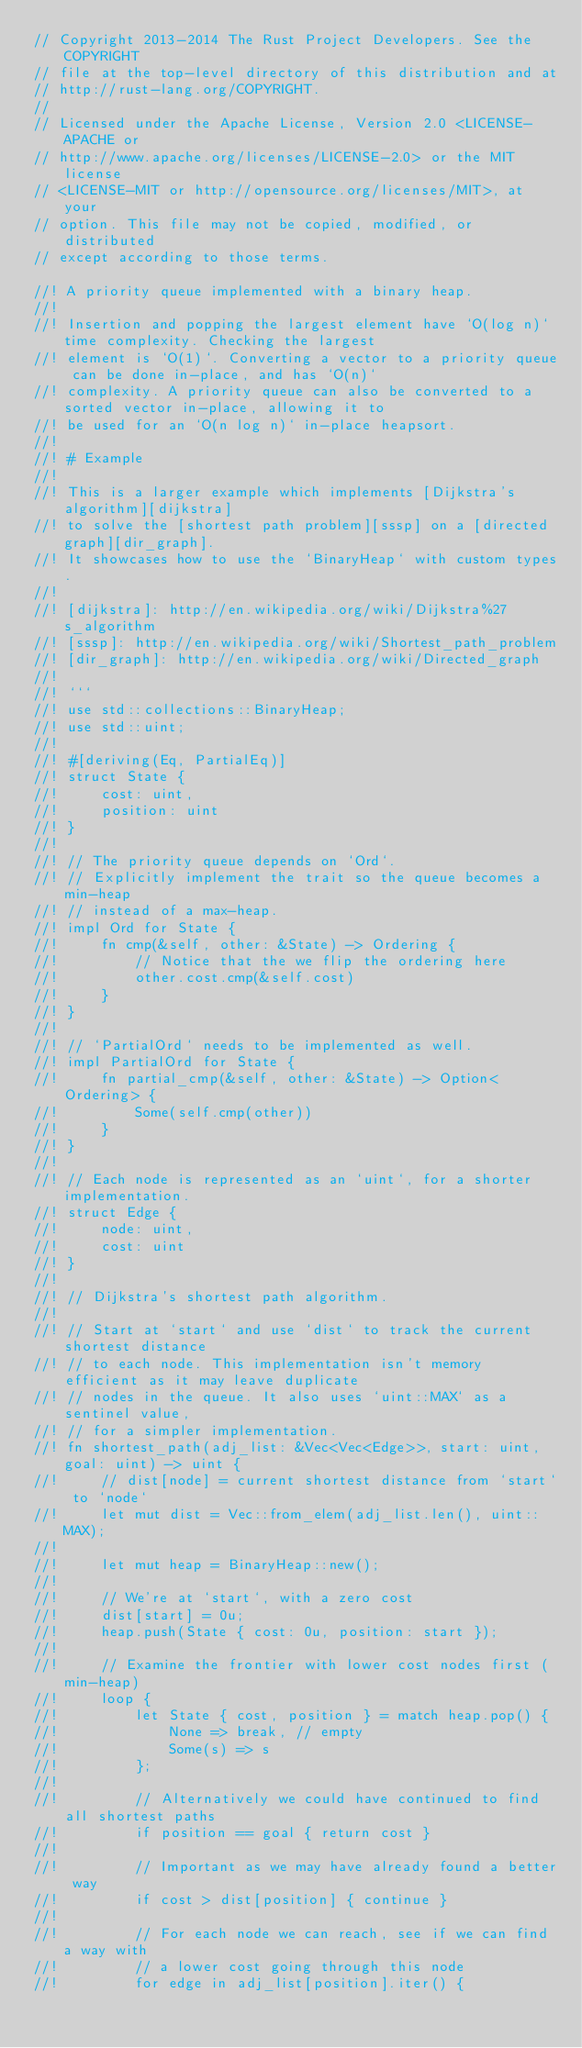<code> <loc_0><loc_0><loc_500><loc_500><_Rust_>// Copyright 2013-2014 The Rust Project Developers. See the COPYRIGHT
// file at the top-level directory of this distribution and at
// http://rust-lang.org/COPYRIGHT.
//
// Licensed under the Apache License, Version 2.0 <LICENSE-APACHE or
// http://www.apache.org/licenses/LICENSE-2.0> or the MIT license
// <LICENSE-MIT or http://opensource.org/licenses/MIT>, at your
// option. This file may not be copied, modified, or distributed
// except according to those terms.

//! A priority queue implemented with a binary heap.
//!
//! Insertion and popping the largest element have `O(log n)` time complexity. Checking the largest
//! element is `O(1)`. Converting a vector to a priority queue can be done in-place, and has `O(n)`
//! complexity. A priority queue can also be converted to a sorted vector in-place, allowing it to
//! be used for an `O(n log n)` in-place heapsort.
//!
//! # Example
//!
//! This is a larger example which implements [Dijkstra's algorithm][dijkstra]
//! to solve the [shortest path problem][sssp] on a [directed graph][dir_graph].
//! It showcases how to use the `BinaryHeap` with custom types.
//!
//! [dijkstra]: http://en.wikipedia.org/wiki/Dijkstra%27s_algorithm
//! [sssp]: http://en.wikipedia.org/wiki/Shortest_path_problem
//! [dir_graph]: http://en.wikipedia.org/wiki/Directed_graph
//!
//! ```
//! use std::collections::BinaryHeap;
//! use std::uint;
//!
//! #[deriving(Eq, PartialEq)]
//! struct State {
//!     cost: uint,
//!     position: uint
//! }
//!
//! // The priority queue depends on `Ord`.
//! // Explicitly implement the trait so the queue becomes a min-heap
//! // instead of a max-heap.
//! impl Ord for State {
//!     fn cmp(&self, other: &State) -> Ordering {
//!         // Notice that the we flip the ordering here
//!         other.cost.cmp(&self.cost)
//!     }
//! }
//!
//! // `PartialOrd` needs to be implemented as well.
//! impl PartialOrd for State {
//!     fn partial_cmp(&self, other: &State) -> Option<Ordering> {
//!         Some(self.cmp(other))
//!     }
//! }
//!
//! // Each node is represented as an `uint`, for a shorter implementation.
//! struct Edge {
//!     node: uint,
//!     cost: uint
//! }
//!
//! // Dijkstra's shortest path algorithm.
//!
//! // Start at `start` and use `dist` to track the current shortest distance
//! // to each node. This implementation isn't memory efficient as it may leave duplicate
//! // nodes in the queue. It also uses `uint::MAX` as a sentinel value,
//! // for a simpler implementation.
//! fn shortest_path(adj_list: &Vec<Vec<Edge>>, start: uint, goal: uint) -> uint {
//!     // dist[node] = current shortest distance from `start` to `node`
//!     let mut dist = Vec::from_elem(adj_list.len(), uint::MAX);
//!
//!     let mut heap = BinaryHeap::new();
//!
//!     // We're at `start`, with a zero cost
//!     dist[start] = 0u;
//!     heap.push(State { cost: 0u, position: start });
//!
//!     // Examine the frontier with lower cost nodes first (min-heap)
//!     loop {
//!         let State { cost, position } = match heap.pop() {
//!             None => break, // empty
//!             Some(s) => s
//!         };
//!
//!         // Alternatively we could have continued to find all shortest paths
//!         if position == goal { return cost }
//!
//!         // Important as we may have already found a better way
//!         if cost > dist[position] { continue }
//!
//!         // For each node we can reach, see if we can find a way with
//!         // a lower cost going through this node
//!         for edge in adj_list[position].iter() {</code> 